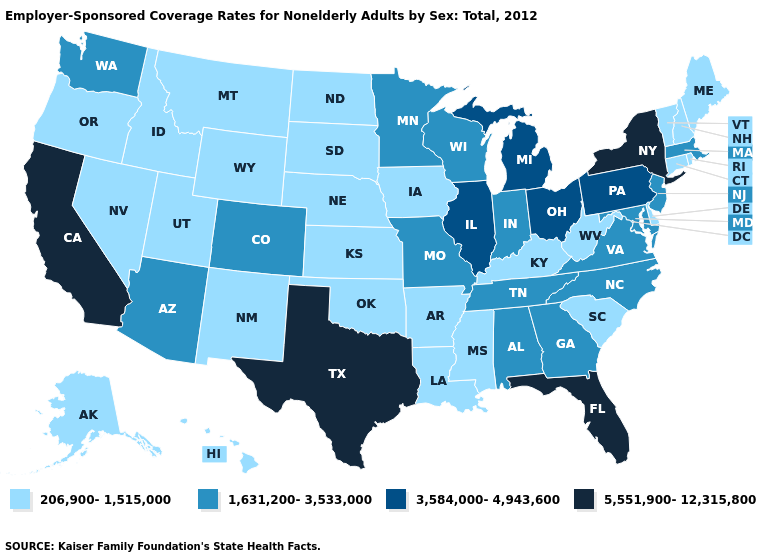Name the states that have a value in the range 1,631,200-3,533,000?
Give a very brief answer. Alabama, Arizona, Colorado, Georgia, Indiana, Maryland, Massachusetts, Minnesota, Missouri, New Jersey, North Carolina, Tennessee, Virginia, Washington, Wisconsin. Among the states that border Rhode Island , which have the lowest value?
Give a very brief answer. Connecticut. What is the value of South Carolina?
Write a very short answer. 206,900-1,515,000. What is the highest value in the West ?
Give a very brief answer. 5,551,900-12,315,800. Does Illinois have the lowest value in the USA?
Short answer required. No. Among the states that border Maine , which have the highest value?
Give a very brief answer. New Hampshire. Does New Jersey have the lowest value in the USA?
Concise answer only. No. What is the lowest value in states that border Indiana?
Write a very short answer. 206,900-1,515,000. What is the lowest value in the USA?
Keep it brief. 206,900-1,515,000. Among the states that border Alabama , does Mississippi have the lowest value?
Answer briefly. Yes. Does Indiana have a higher value than Illinois?
Be succinct. No. Which states have the highest value in the USA?
Short answer required. California, Florida, New York, Texas. Name the states that have a value in the range 1,631,200-3,533,000?
Short answer required. Alabama, Arizona, Colorado, Georgia, Indiana, Maryland, Massachusetts, Minnesota, Missouri, New Jersey, North Carolina, Tennessee, Virginia, Washington, Wisconsin. What is the value of Arkansas?
Answer briefly. 206,900-1,515,000. Does Oklahoma have the lowest value in the South?
Give a very brief answer. Yes. 